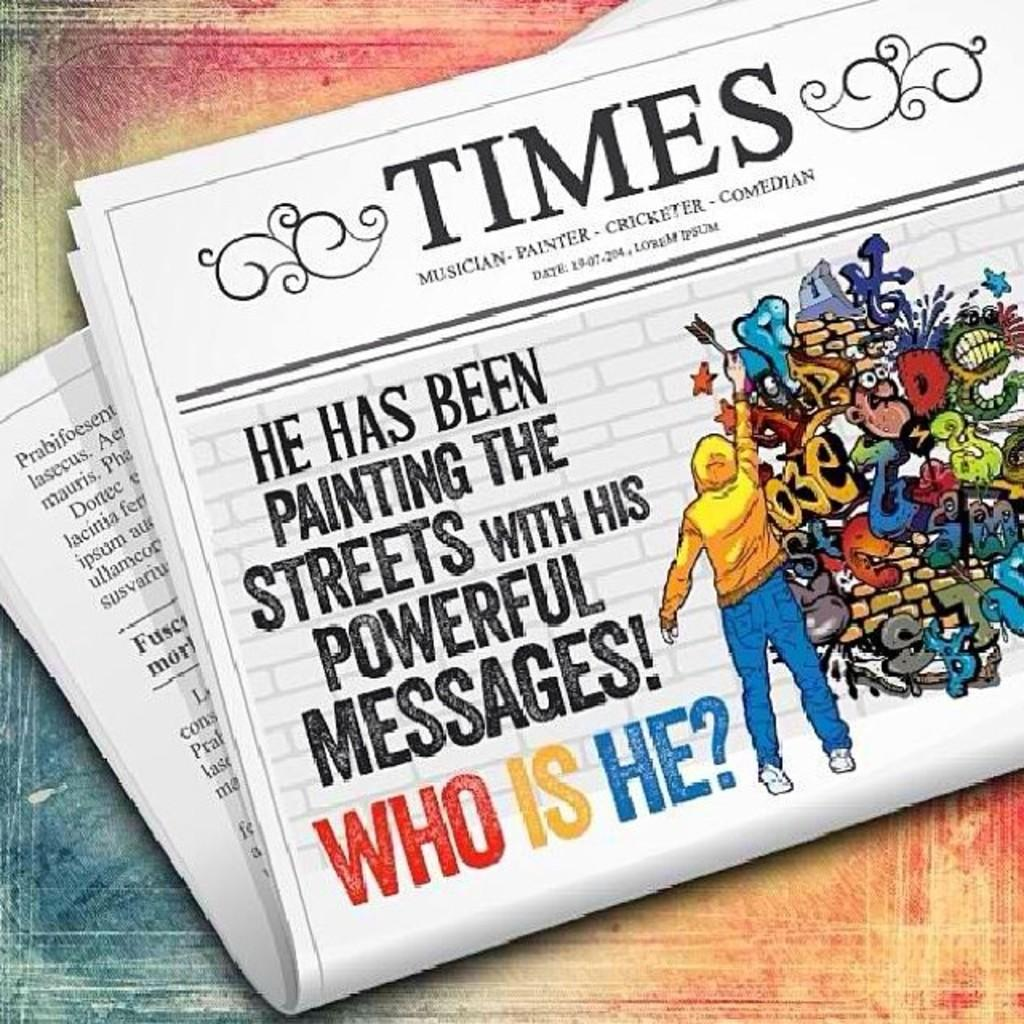<image>
Summarize the visual content of the image. A mural of a TIMES newspaper about a person who is painting the streets with powerful messages. 